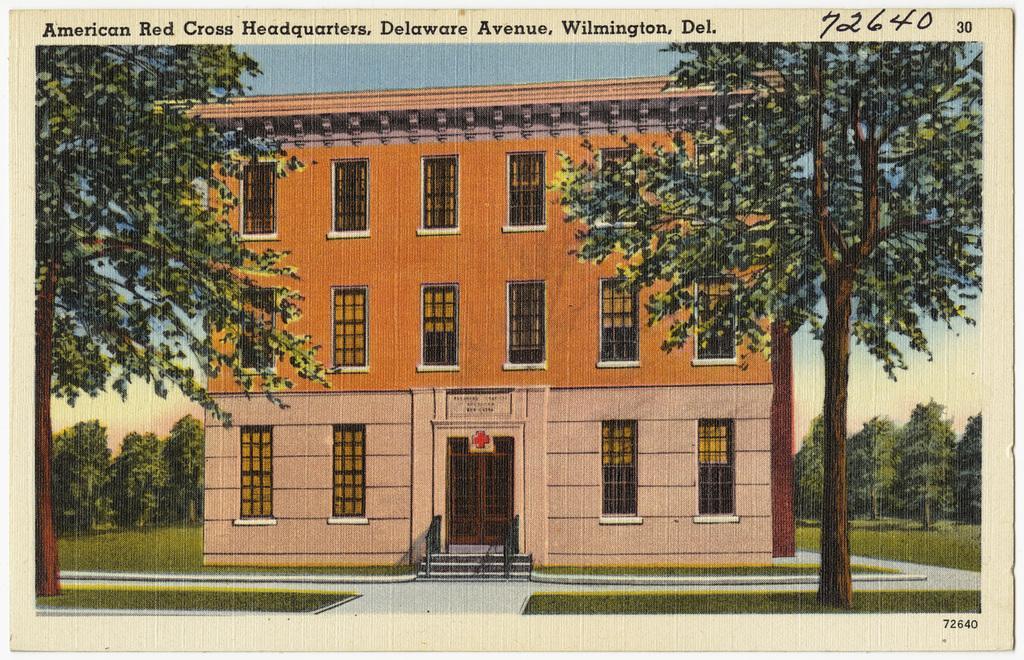Can you describe this image briefly? In this image we can see the photograph which includes the house, windows, trees, stairs, some written text at the top. 